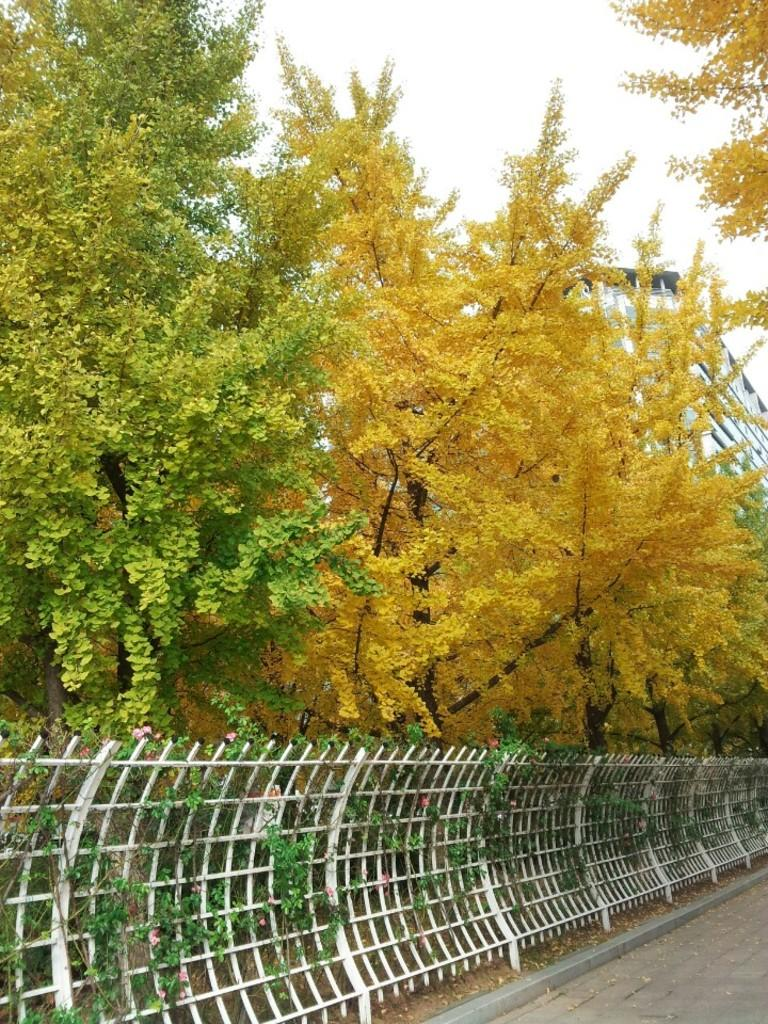What can be seen in the image that might be used for support or safety? There is a railing in the image that might be used for support or safety. What type of natural scenery is visible in the background of the image? There are trees in the background of the image. What colors can be observed on the trees in the image? The trees have green and yellow colors. What part of the natural environment is visible in the image? The sky is visible in the image. What type of soap is being used to clean the linen in the image? There is no soap or linen present in the image; it only features a railing and trees in the background. 